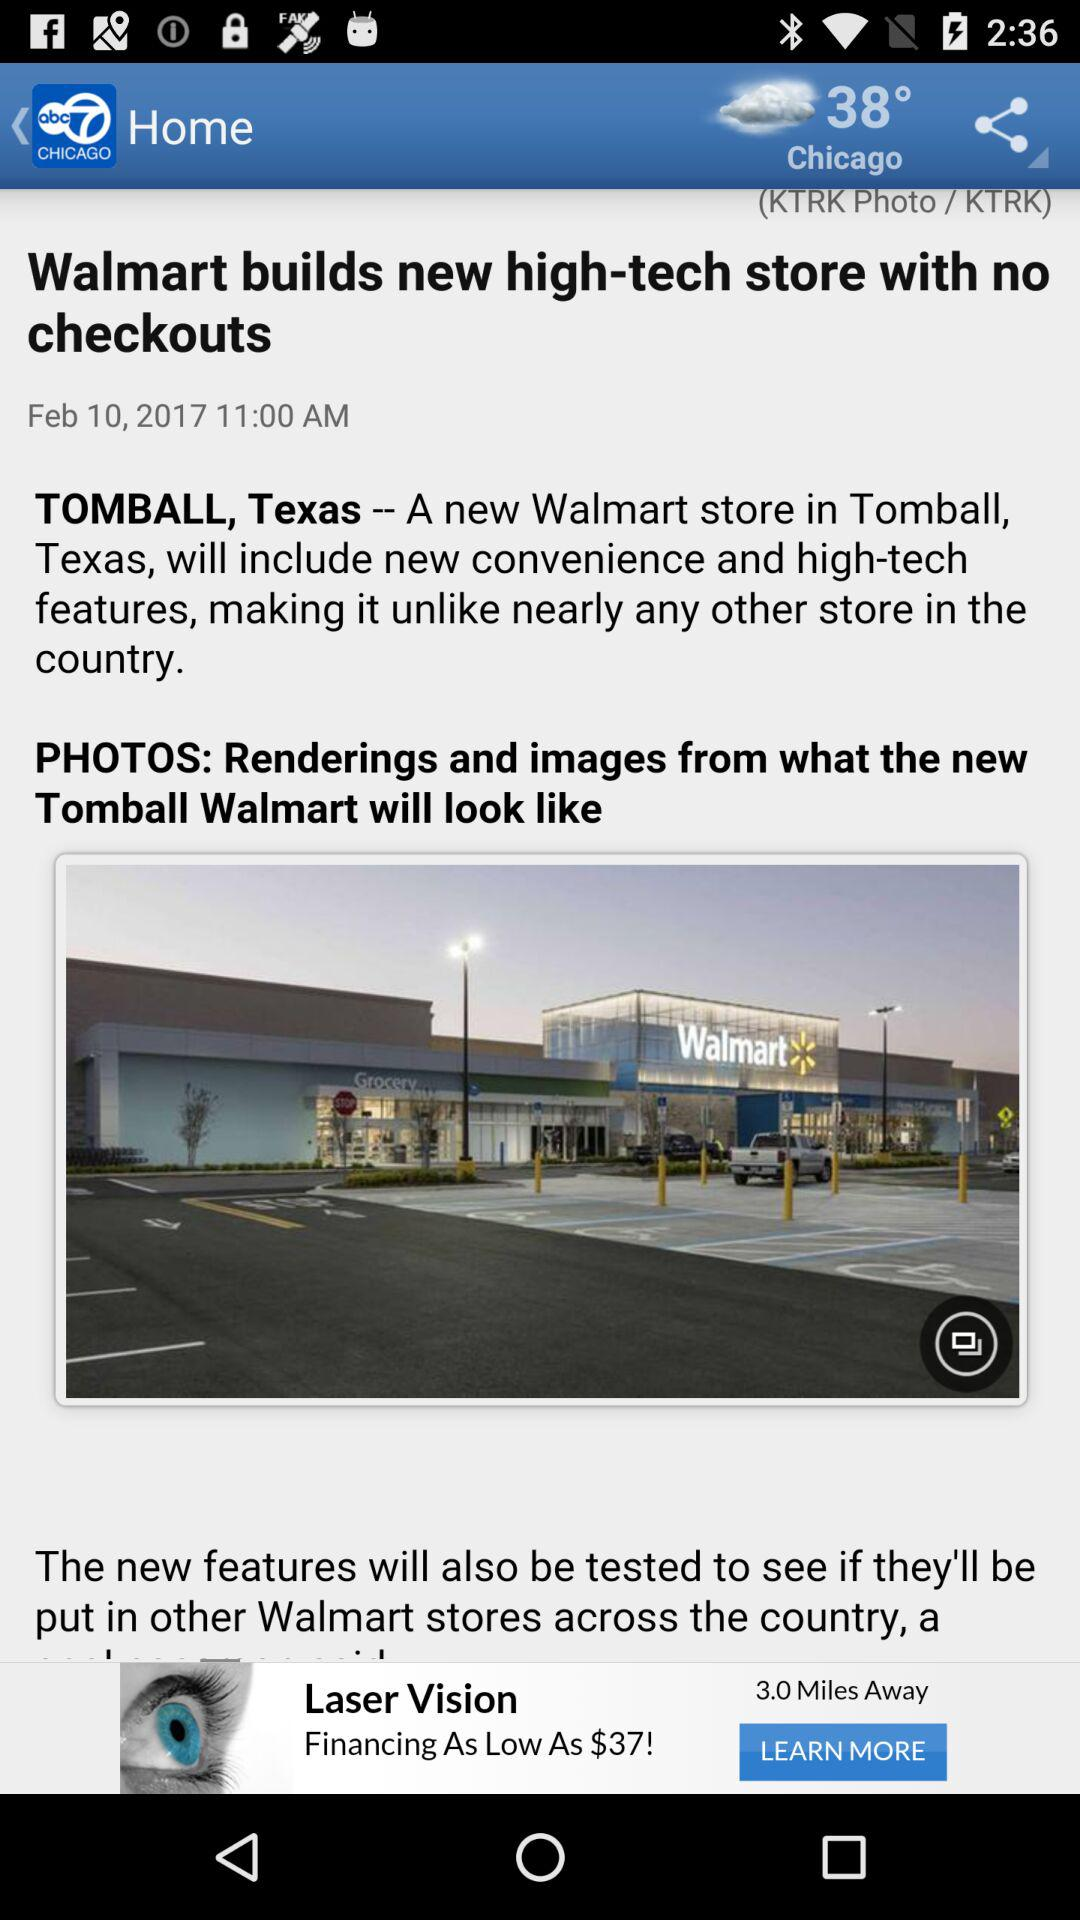What is the temperature in Chicago? The temperature in Chicago is 38°. 